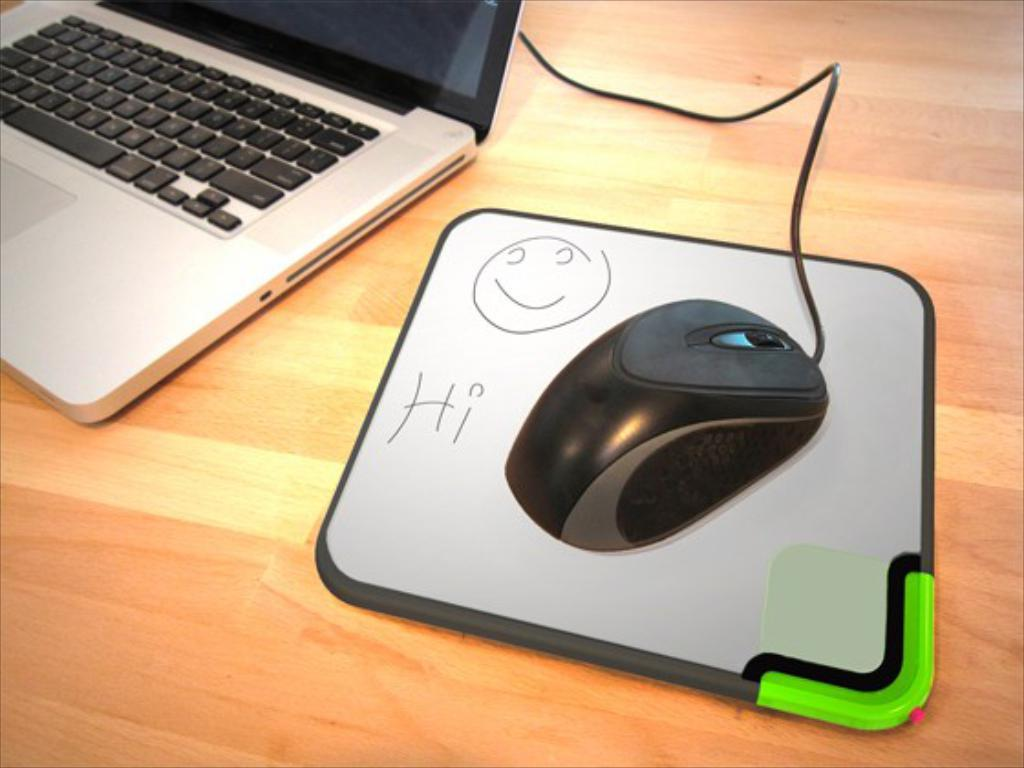What is the main object in the center of the image? There is a table in the center of the image. What electronic device is placed on the table? There is a laptop on the table. What is used for controlling the laptop in the image? There is a mouse on the table. Can you describe the color pattern of the object on the table? There is a white and black color object on the table. What time of day is depicted in the image, and how does the plot unfold? The provided facts do not mention any specific time of day or plot, as the image only shows a table with a laptop, a mouse, and a white and black color object. 